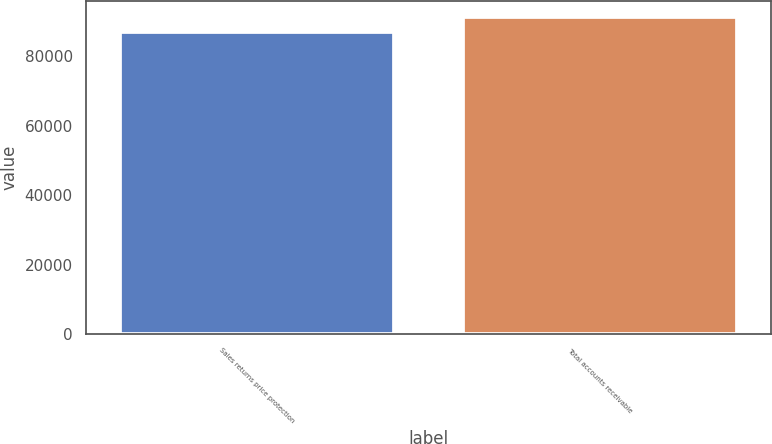Convert chart. <chart><loc_0><loc_0><loc_500><loc_500><bar_chart><fcel>Sales returns price protection<fcel>Total accounts receivable<nl><fcel>87178<fcel>91509<nl></chart> 